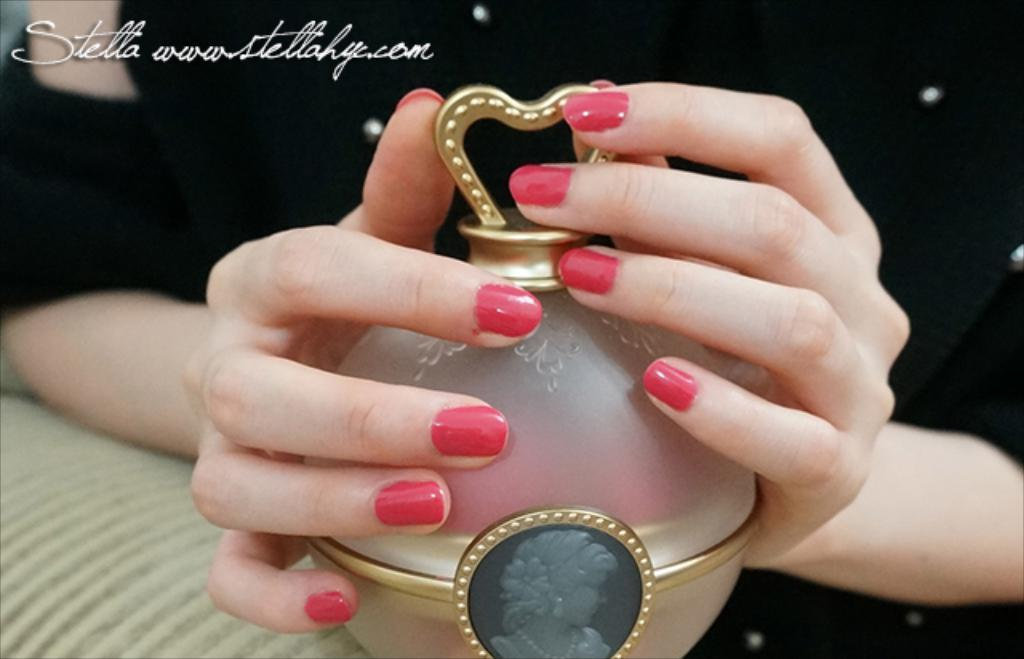<image>
Share a concise interpretation of the image provided. A woman hands around a decorative orb and the name, Stella, above. 